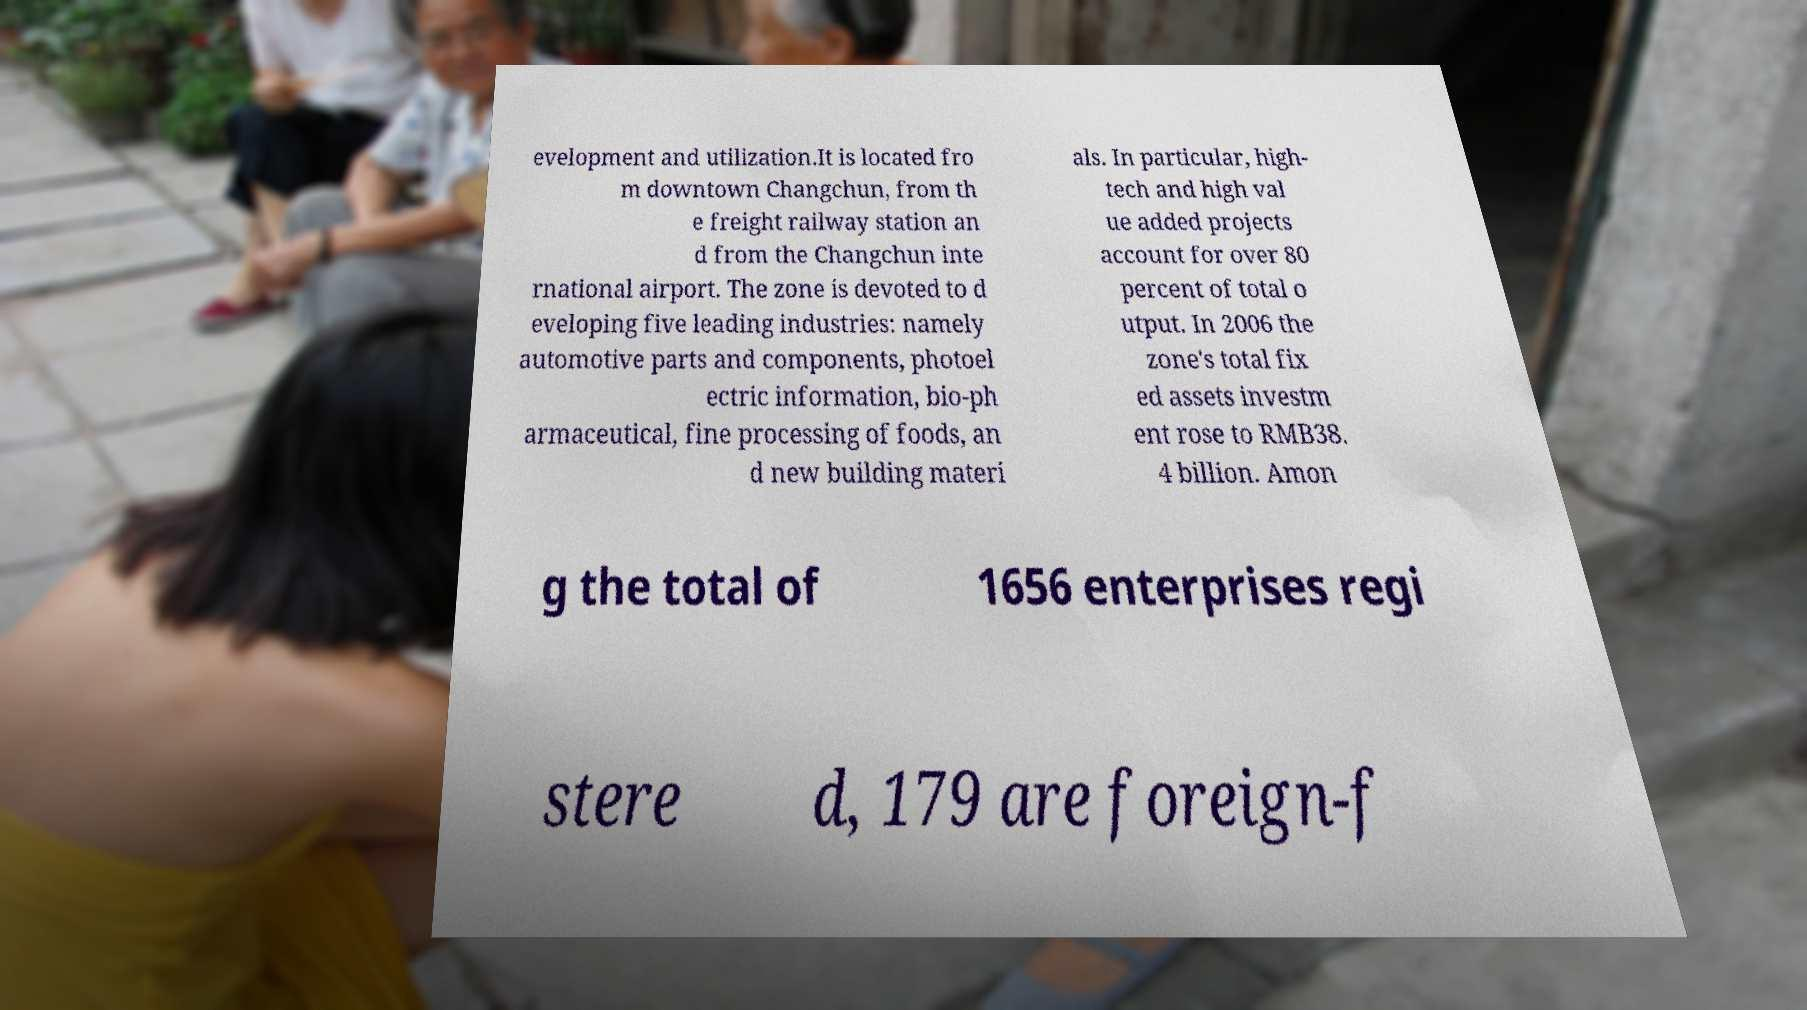For documentation purposes, I need the text within this image transcribed. Could you provide that? evelopment and utilization.It is located fro m downtown Changchun, from th e freight railway station an d from the Changchun inte rnational airport. The zone is devoted to d eveloping five leading industries: namely automotive parts and components, photoel ectric information, bio-ph armaceutical, fine processing of foods, an d new building materi als. In particular, high- tech and high val ue added projects account for over 80 percent of total o utput. In 2006 the zone's total fix ed assets investm ent rose to RMB38. 4 billion. Amon g the total of 1656 enterprises regi stere d, 179 are foreign-f 